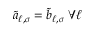<formula> <loc_0><loc_0><loc_500><loc_500>\tilde { a } _ { \ell , \sigma } = \tilde { b } _ { \ell , \sigma } \, \forall \ell</formula> 